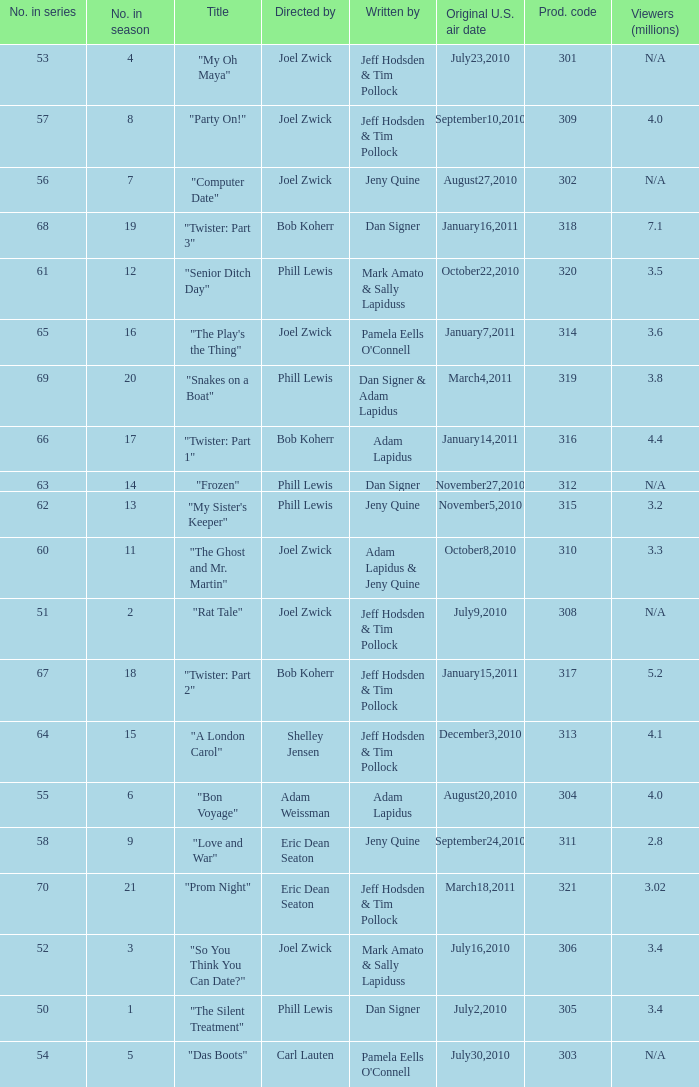Which US air date had 4.4 million viewers? January14,2011. 